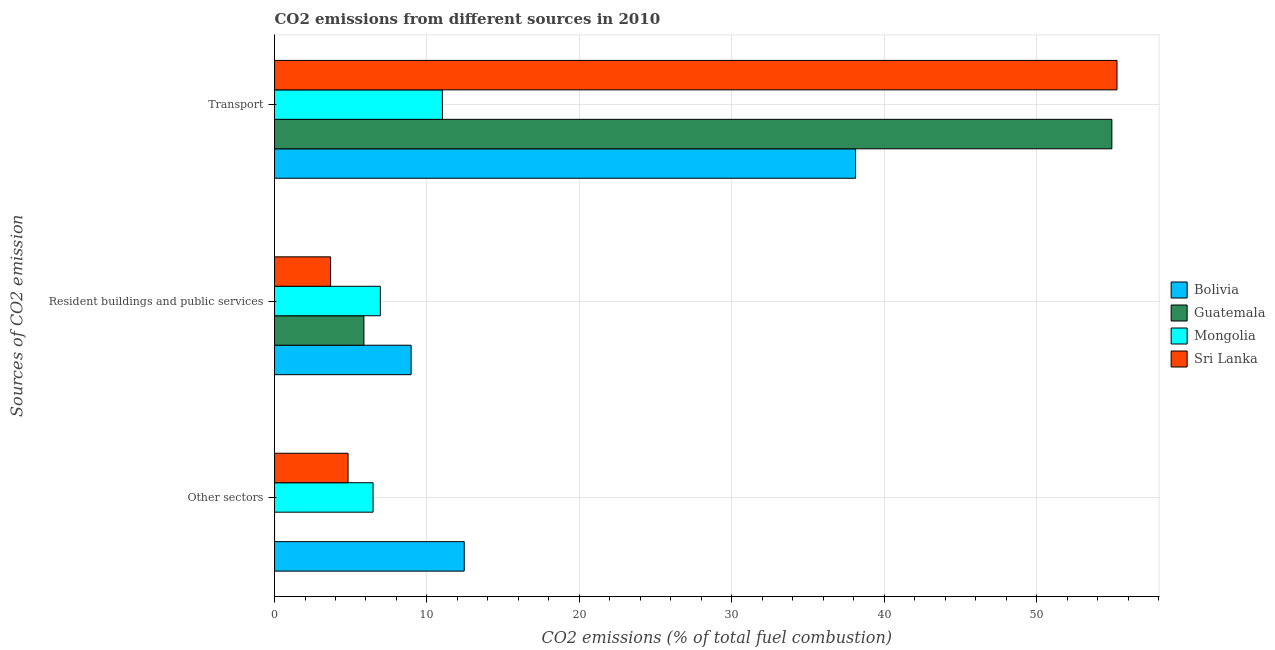How many different coloured bars are there?
Keep it short and to the point. 4. How many groups of bars are there?
Your response must be concise. 3. How many bars are there on the 1st tick from the top?
Offer a very short reply. 4. How many bars are there on the 3rd tick from the bottom?
Offer a terse response. 4. What is the label of the 1st group of bars from the top?
Your response must be concise. Transport. What is the percentage of co2 emissions from other sectors in Sri Lanka?
Offer a terse response. 4.82. Across all countries, what is the maximum percentage of co2 emissions from other sectors?
Make the answer very short. 12.45. Across all countries, what is the minimum percentage of co2 emissions from resident buildings and public services?
Your answer should be very brief. 3.68. In which country was the percentage of co2 emissions from other sectors maximum?
Your answer should be very brief. Bolivia. In which country was the percentage of co2 emissions from resident buildings and public services minimum?
Ensure brevity in your answer.  Sri Lanka. What is the total percentage of co2 emissions from other sectors in the graph?
Your response must be concise. 23.74. What is the difference between the percentage of co2 emissions from transport in Bolivia and that in Mongolia?
Offer a very short reply. 27.11. What is the difference between the percentage of co2 emissions from resident buildings and public services in Guatemala and the percentage of co2 emissions from transport in Mongolia?
Your answer should be compact. -5.15. What is the average percentage of co2 emissions from transport per country?
Make the answer very short. 39.84. What is the difference between the percentage of co2 emissions from resident buildings and public services and percentage of co2 emissions from transport in Sri Lanka?
Provide a short and direct response. -51.59. What is the ratio of the percentage of co2 emissions from transport in Mongolia to that in Guatemala?
Give a very brief answer. 0.2. Is the percentage of co2 emissions from resident buildings and public services in Mongolia less than that in Guatemala?
Offer a terse response. No. What is the difference between the highest and the second highest percentage of co2 emissions from other sectors?
Give a very brief answer. 5.98. What is the difference between the highest and the lowest percentage of co2 emissions from transport?
Offer a very short reply. 44.26. In how many countries, is the percentage of co2 emissions from transport greater than the average percentage of co2 emissions from transport taken over all countries?
Offer a terse response. 2. What does the 2nd bar from the top in Transport represents?
Give a very brief answer. Mongolia. What does the 3rd bar from the bottom in Other sectors represents?
Your answer should be compact. Mongolia. How many bars are there?
Your answer should be compact. 12. How many countries are there in the graph?
Offer a very short reply. 4. What is the difference between two consecutive major ticks on the X-axis?
Provide a succinct answer. 10. Are the values on the major ticks of X-axis written in scientific E-notation?
Provide a succinct answer. No. Does the graph contain any zero values?
Your response must be concise. No. Where does the legend appear in the graph?
Make the answer very short. Center right. How are the legend labels stacked?
Ensure brevity in your answer.  Vertical. What is the title of the graph?
Your response must be concise. CO2 emissions from different sources in 2010. Does "Iran" appear as one of the legend labels in the graph?
Your answer should be compact. No. What is the label or title of the X-axis?
Offer a very short reply. CO2 emissions (% of total fuel combustion). What is the label or title of the Y-axis?
Offer a terse response. Sources of CO2 emission. What is the CO2 emissions (% of total fuel combustion) of Bolivia in Other sectors?
Keep it short and to the point. 12.45. What is the CO2 emissions (% of total fuel combustion) of Guatemala in Other sectors?
Ensure brevity in your answer.  1.6957218729001e-16. What is the CO2 emissions (% of total fuel combustion) in Mongolia in Other sectors?
Your response must be concise. 6.46. What is the CO2 emissions (% of total fuel combustion) of Sri Lanka in Other sectors?
Offer a very short reply. 4.82. What is the CO2 emissions (% of total fuel combustion) of Bolivia in Resident buildings and public services?
Offer a very short reply. 8.96. What is the CO2 emissions (% of total fuel combustion) of Guatemala in Resident buildings and public services?
Give a very brief answer. 5.87. What is the CO2 emissions (% of total fuel combustion) of Mongolia in Resident buildings and public services?
Give a very brief answer. 6.94. What is the CO2 emissions (% of total fuel combustion) of Sri Lanka in Resident buildings and public services?
Keep it short and to the point. 3.68. What is the CO2 emissions (% of total fuel combustion) of Bolivia in Transport?
Give a very brief answer. 38.12. What is the CO2 emissions (% of total fuel combustion) of Guatemala in Transport?
Offer a very short reply. 54.94. What is the CO2 emissions (% of total fuel combustion) of Mongolia in Transport?
Provide a succinct answer. 11.01. What is the CO2 emissions (% of total fuel combustion) of Sri Lanka in Transport?
Provide a succinct answer. 55.27. Across all Sources of CO2 emission, what is the maximum CO2 emissions (% of total fuel combustion) of Bolivia?
Your answer should be very brief. 38.12. Across all Sources of CO2 emission, what is the maximum CO2 emissions (% of total fuel combustion) in Guatemala?
Your response must be concise. 54.94. Across all Sources of CO2 emission, what is the maximum CO2 emissions (% of total fuel combustion) in Mongolia?
Make the answer very short. 11.01. Across all Sources of CO2 emission, what is the maximum CO2 emissions (% of total fuel combustion) of Sri Lanka?
Provide a short and direct response. 55.27. Across all Sources of CO2 emission, what is the minimum CO2 emissions (% of total fuel combustion) in Bolivia?
Ensure brevity in your answer.  8.96. Across all Sources of CO2 emission, what is the minimum CO2 emissions (% of total fuel combustion) in Guatemala?
Make the answer very short. 1.6957218729001e-16. Across all Sources of CO2 emission, what is the minimum CO2 emissions (% of total fuel combustion) of Mongolia?
Your response must be concise. 6.46. Across all Sources of CO2 emission, what is the minimum CO2 emissions (% of total fuel combustion) in Sri Lanka?
Your response must be concise. 3.68. What is the total CO2 emissions (% of total fuel combustion) of Bolivia in the graph?
Offer a terse response. 59.53. What is the total CO2 emissions (% of total fuel combustion) in Guatemala in the graph?
Keep it short and to the point. 60.8. What is the total CO2 emissions (% of total fuel combustion) in Mongolia in the graph?
Make the answer very short. 24.42. What is the total CO2 emissions (% of total fuel combustion) of Sri Lanka in the graph?
Give a very brief answer. 63.78. What is the difference between the CO2 emissions (% of total fuel combustion) of Bolivia in Other sectors and that in Resident buildings and public services?
Give a very brief answer. 3.49. What is the difference between the CO2 emissions (% of total fuel combustion) of Guatemala in Other sectors and that in Resident buildings and public services?
Your response must be concise. -5.87. What is the difference between the CO2 emissions (% of total fuel combustion) of Mongolia in Other sectors and that in Resident buildings and public services?
Give a very brief answer. -0.48. What is the difference between the CO2 emissions (% of total fuel combustion) of Sri Lanka in Other sectors and that in Resident buildings and public services?
Provide a short and direct response. 1.14. What is the difference between the CO2 emissions (% of total fuel combustion) of Bolivia in Other sectors and that in Transport?
Your answer should be compact. -25.68. What is the difference between the CO2 emissions (% of total fuel combustion) of Guatemala in Other sectors and that in Transport?
Your answer should be very brief. -54.94. What is the difference between the CO2 emissions (% of total fuel combustion) in Mongolia in Other sectors and that in Transport?
Your answer should be compact. -4.55. What is the difference between the CO2 emissions (% of total fuel combustion) in Sri Lanka in Other sectors and that in Transport?
Offer a terse response. -50.45. What is the difference between the CO2 emissions (% of total fuel combustion) of Bolivia in Resident buildings and public services and that in Transport?
Keep it short and to the point. -29.16. What is the difference between the CO2 emissions (% of total fuel combustion) of Guatemala in Resident buildings and public services and that in Transport?
Ensure brevity in your answer.  -49.07. What is the difference between the CO2 emissions (% of total fuel combustion) of Mongolia in Resident buildings and public services and that in Transport?
Provide a succinct answer. -4.07. What is the difference between the CO2 emissions (% of total fuel combustion) in Sri Lanka in Resident buildings and public services and that in Transport?
Provide a short and direct response. -51.59. What is the difference between the CO2 emissions (% of total fuel combustion) of Bolivia in Other sectors and the CO2 emissions (% of total fuel combustion) of Guatemala in Resident buildings and public services?
Give a very brief answer. 6.58. What is the difference between the CO2 emissions (% of total fuel combustion) in Bolivia in Other sectors and the CO2 emissions (% of total fuel combustion) in Mongolia in Resident buildings and public services?
Provide a short and direct response. 5.5. What is the difference between the CO2 emissions (% of total fuel combustion) in Bolivia in Other sectors and the CO2 emissions (% of total fuel combustion) in Sri Lanka in Resident buildings and public services?
Make the answer very short. 8.77. What is the difference between the CO2 emissions (% of total fuel combustion) in Guatemala in Other sectors and the CO2 emissions (% of total fuel combustion) in Mongolia in Resident buildings and public services?
Keep it short and to the point. -6.94. What is the difference between the CO2 emissions (% of total fuel combustion) in Guatemala in Other sectors and the CO2 emissions (% of total fuel combustion) in Sri Lanka in Resident buildings and public services?
Give a very brief answer. -3.68. What is the difference between the CO2 emissions (% of total fuel combustion) in Mongolia in Other sectors and the CO2 emissions (% of total fuel combustion) in Sri Lanka in Resident buildings and public services?
Your answer should be compact. 2.79. What is the difference between the CO2 emissions (% of total fuel combustion) of Bolivia in Other sectors and the CO2 emissions (% of total fuel combustion) of Guatemala in Transport?
Make the answer very short. -42.49. What is the difference between the CO2 emissions (% of total fuel combustion) of Bolivia in Other sectors and the CO2 emissions (% of total fuel combustion) of Mongolia in Transport?
Your answer should be compact. 1.43. What is the difference between the CO2 emissions (% of total fuel combustion) in Bolivia in Other sectors and the CO2 emissions (% of total fuel combustion) in Sri Lanka in Transport?
Your response must be concise. -42.83. What is the difference between the CO2 emissions (% of total fuel combustion) of Guatemala in Other sectors and the CO2 emissions (% of total fuel combustion) of Mongolia in Transport?
Your answer should be very brief. -11.01. What is the difference between the CO2 emissions (% of total fuel combustion) in Guatemala in Other sectors and the CO2 emissions (% of total fuel combustion) in Sri Lanka in Transport?
Offer a very short reply. -55.27. What is the difference between the CO2 emissions (% of total fuel combustion) of Mongolia in Other sectors and the CO2 emissions (% of total fuel combustion) of Sri Lanka in Transport?
Provide a succinct answer. -48.81. What is the difference between the CO2 emissions (% of total fuel combustion) of Bolivia in Resident buildings and public services and the CO2 emissions (% of total fuel combustion) of Guatemala in Transport?
Offer a terse response. -45.97. What is the difference between the CO2 emissions (% of total fuel combustion) of Bolivia in Resident buildings and public services and the CO2 emissions (% of total fuel combustion) of Mongolia in Transport?
Make the answer very short. -2.05. What is the difference between the CO2 emissions (% of total fuel combustion) in Bolivia in Resident buildings and public services and the CO2 emissions (% of total fuel combustion) in Sri Lanka in Transport?
Your answer should be very brief. -46.31. What is the difference between the CO2 emissions (% of total fuel combustion) in Guatemala in Resident buildings and public services and the CO2 emissions (% of total fuel combustion) in Mongolia in Transport?
Keep it short and to the point. -5.15. What is the difference between the CO2 emissions (% of total fuel combustion) of Guatemala in Resident buildings and public services and the CO2 emissions (% of total fuel combustion) of Sri Lanka in Transport?
Offer a terse response. -49.41. What is the difference between the CO2 emissions (% of total fuel combustion) in Mongolia in Resident buildings and public services and the CO2 emissions (% of total fuel combustion) in Sri Lanka in Transport?
Provide a succinct answer. -48.33. What is the average CO2 emissions (% of total fuel combustion) of Bolivia per Sources of CO2 emission?
Your response must be concise. 19.84. What is the average CO2 emissions (% of total fuel combustion) of Guatemala per Sources of CO2 emission?
Give a very brief answer. 20.27. What is the average CO2 emissions (% of total fuel combustion) of Mongolia per Sources of CO2 emission?
Your response must be concise. 8.14. What is the average CO2 emissions (% of total fuel combustion) of Sri Lanka per Sources of CO2 emission?
Keep it short and to the point. 21.26. What is the difference between the CO2 emissions (% of total fuel combustion) of Bolivia and CO2 emissions (% of total fuel combustion) of Guatemala in Other sectors?
Offer a very short reply. 12.45. What is the difference between the CO2 emissions (% of total fuel combustion) in Bolivia and CO2 emissions (% of total fuel combustion) in Mongolia in Other sectors?
Offer a terse response. 5.98. What is the difference between the CO2 emissions (% of total fuel combustion) of Bolivia and CO2 emissions (% of total fuel combustion) of Sri Lanka in Other sectors?
Make the answer very short. 7.62. What is the difference between the CO2 emissions (% of total fuel combustion) of Guatemala and CO2 emissions (% of total fuel combustion) of Mongolia in Other sectors?
Your answer should be compact. -6.46. What is the difference between the CO2 emissions (% of total fuel combustion) in Guatemala and CO2 emissions (% of total fuel combustion) in Sri Lanka in Other sectors?
Give a very brief answer. -4.82. What is the difference between the CO2 emissions (% of total fuel combustion) of Mongolia and CO2 emissions (% of total fuel combustion) of Sri Lanka in Other sectors?
Provide a succinct answer. 1.64. What is the difference between the CO2 emissions (% of total fuel combustion) in Bolivia and CO2 emissions (% of total fuel combustion) in Guatemala in Resident buildings and public services?
Make the answer very short. 3.1. What is the difference between the CO2 emissions (% of total fuel combustion) in Bolivia and CO2 emissions (% of total fuel combustion) in Mongolia in Resident buildings and public services?
Ensure brevity in your answer.  2.02. What is the difference between the CO2 emissions (% of total fuel combustion) of Bolivia and CO2 emissions (% of total fuel combustion) of Sri Lanka in Resident buildings and public services?
Offer a terse response. 5.28. What is the difference between the CO2 emissions (% of total fuel combustion) in Guatemala and CO2 emissions (% of total fuel combustion) in Mongolia in Resident buildings and public services?
Offer a very short reply. -1.08. What is the difference between the CO2 emissions (% of total fuel combustion) in Guatemala and CO2 emissions (% of total fuel combustion) in Sri Lanka in Resident buildings and public services?
Provide a short and direct response. 2.19. What is the difference between the CO2 emissions (% of total fuel combustion) in Mongolia and CO2 emissions (% of total fuel combustion) in Sri Lanka in Resident buildings and public services?
Your answer should be very brief. 3.26. What is the difference between the CO2 emissions (% of total fuel combustion) of Bolivia and CO2 emissions (% of total fuel combustion) of Guatemala in Transport?
Make the answer very short. -16.81. What is the difference between the CO2 emissions (% of total fuel combustion) of Bolivia and CO2 emissions (% of total fuel combustion) of Mongolia in Transport?
Keep it short and to the point. 27.11. What is the difference between the CO2 emissions (% of total fuel combustion) in Bolivia and CO2 emissions (% of total fuel combustion) in Sri Lanka in Transport?
Ensure brevity in your answer.  -17.15. What is the difference between the CO2 emissions (% of total fuel combustion) in Guatemala and CO2 emissions (% of total fuel combustion) in Mongolia in Transport?
Ensure brevity in your answer.  43.92. What is the difference between the CO2 emissions (% of total fuel combustion) in Guatemala and CO2 emissions (% of total fuel combustion) in Sri Lanka in Transport?
Keep it short and to the point. -0.34. What is the difference between the CO2 emissions (% of total fuel combustion) in Mongolia and CO2 emissions (% of total fuel combustion) in Sri Lanka in Transport?
Provide a short and direct response. -44.26. What is the ratio of the CO2 emissions (% of total fuel combustion) in Bolivia in Other sectors to that in Resident buildings and public services?
Ensure brevity in your answer.  1.39. What is the ratio of the CO2 emissions (% of total fuel combustion) in Guatemala in Other sectors to that in Resident buildings and public services?
Make the answer very short. 0. What is the ratio of the CO2 emissions (% of total fuel combustion) in Mongolia in Other sectors to that in Resident buildings and public services?
Keep it short and to the point. 0.93. What is the ratio of the CO2 emissions (% of total fuel combustion) of Sri Lanka in Other sectors to that in Resident buildings and public services?
Keep it short and to the point. 1.31. What is the ratio of the CO2 emissions (% of total fuel combustion) in Bolivia in Other sectors to that in Transport?
Your response must be concise. 0.33. What is the ratio of the CO2 emissions (% of total fuel combustion) of Guatemala in Other sectors to that in Transport?
Ensure brevity in your answer.  0. What is the ratio of the CO2 emissions (% of total fuel combustion) of Mongolia in Other sectors to that in Transport?
Provide a succinct answer. 0.59. What is the ratio of the CO2 emissions (% of total fuel combustion) of Sri Lanka in Other sectors to that in Transport?
Your answer should be very brief. 0.09. What is the ratio of the CO2 emissions (% of total fuel combustion) in Bolivia in Resident buildings and public services to that in Transport?
Keep it short and to the point. 0.24. What is the ratio of the CO2 emissions (% of total fuel combustion) in Guatemala in Resident buildings and public services to that in Transport?
Make the answer very short. 0.11. What is the ratio of the CO2 emissions (% of total fuel combustion) of Mongolia in Resident buildings and public services to that in Transport?
Offer a very short reply. 0.63. What is the ratio of the CO2 emissions (% of total fuel combustion) in Sri Lanka in Resident buildings and public services to that in Transport?
Ensure brevity in your answer.  0.07. What is the difference between the highest and the second highest CO2 emissions (% of total fuel combustion) in Bolivia?
Offer a terse response. 25.68. What is the difference between the highest and the second highest CO2 emissions (% of total fuel combustion) of Guatemala?
Your response must be concise. 49.07. What is the difference between the highest and the second highest CO2 emissions (% of total fuel combustion) in Mongolia?
Your response must be concise. 4.07. What is the difference between the highest and the second highest CO2 emissions (% of total fuel combustion) in Sri Lanka?
Provide a succinct answer. 50.45. What is the difference between the highest and the lowest CO2 emissions (% of total fuel combustion) in Bolivia?
Ensure brevity in your answer.  29.16. What is the difference between the highest and the lowest CO2 emissions (% of total fuel combustion) in Guatemala?
Your response must be concise. 54.94. What is the difference between the highest and the lowest CO2 emissions (% of total fuel combustion) of Mongolia?
Offer a terse response. 4.55. What is the difference between the highest and the lowest CO2 emissions (% of total fuel combustion) of Sri Lanka?
Your answer should be very brief. 51.59. 